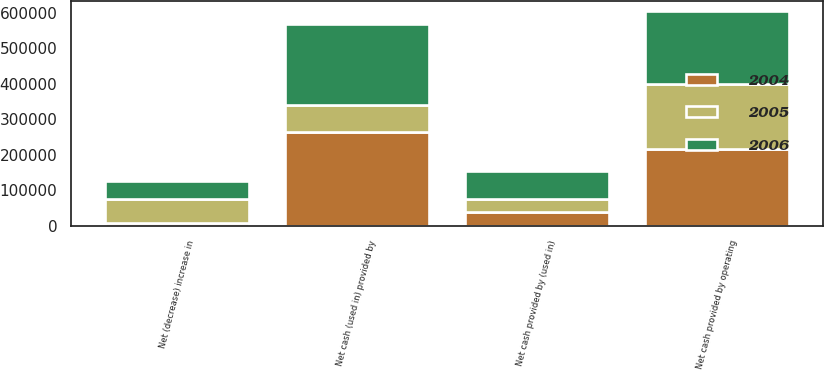Convert chart to OTSL. <chart><loc_0><loc_0><loc_500><loc_500><stacked_bar_chart><ecel><fcel>Net cash provided by operating<fcel>Net cash provided by (used in)<fcel>Net cash (used in) provided by<fcel>Net (decrease) increase in<nl><fcel>2004<fcel>216815<fcel>38231<fcel>263458<fcel>8412<nl><fcel>2006<fcel>205403<fcel>77753<fcel>226513<fcel>52862<nl><fcel>2005<fcel>181522<fcel>38318<fcel>77753<fcel>65451<nl></chart> 